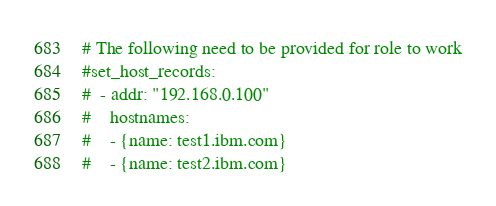Convert code to text. <code><loc_0><loc_0><loc_500><loc_500><_YAML_># The following need to be provided for role to work
#set_host_records:
#  - addr: "192.168.0.100"
#    hostnames:
#    - {name: test1.ibm.com}
#    - {name: test2.ibm.com}</code> 